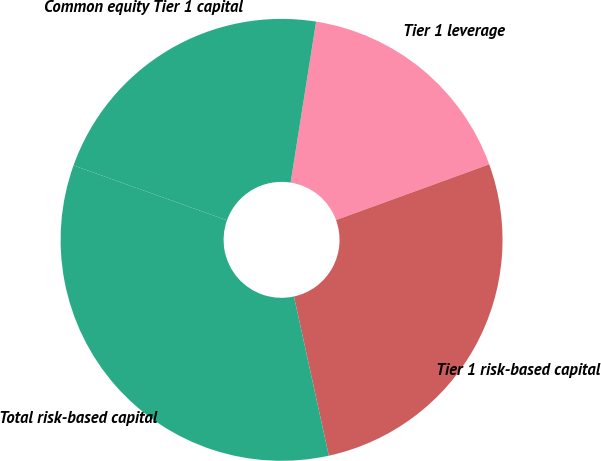Convert chart. <chart><loc_0><loc_0><loc_500><loc_500><pie_chart><fcel>Tier 1 leverage<fcel>Tier 1 risk-based capital<fcel>Total risk-based capital<fcel>Common equity Tier 1 capital<nl><fcel>16.95%<fcel>27.12%<fcel>33.9%<fcel>22.03%<nl></chart> 